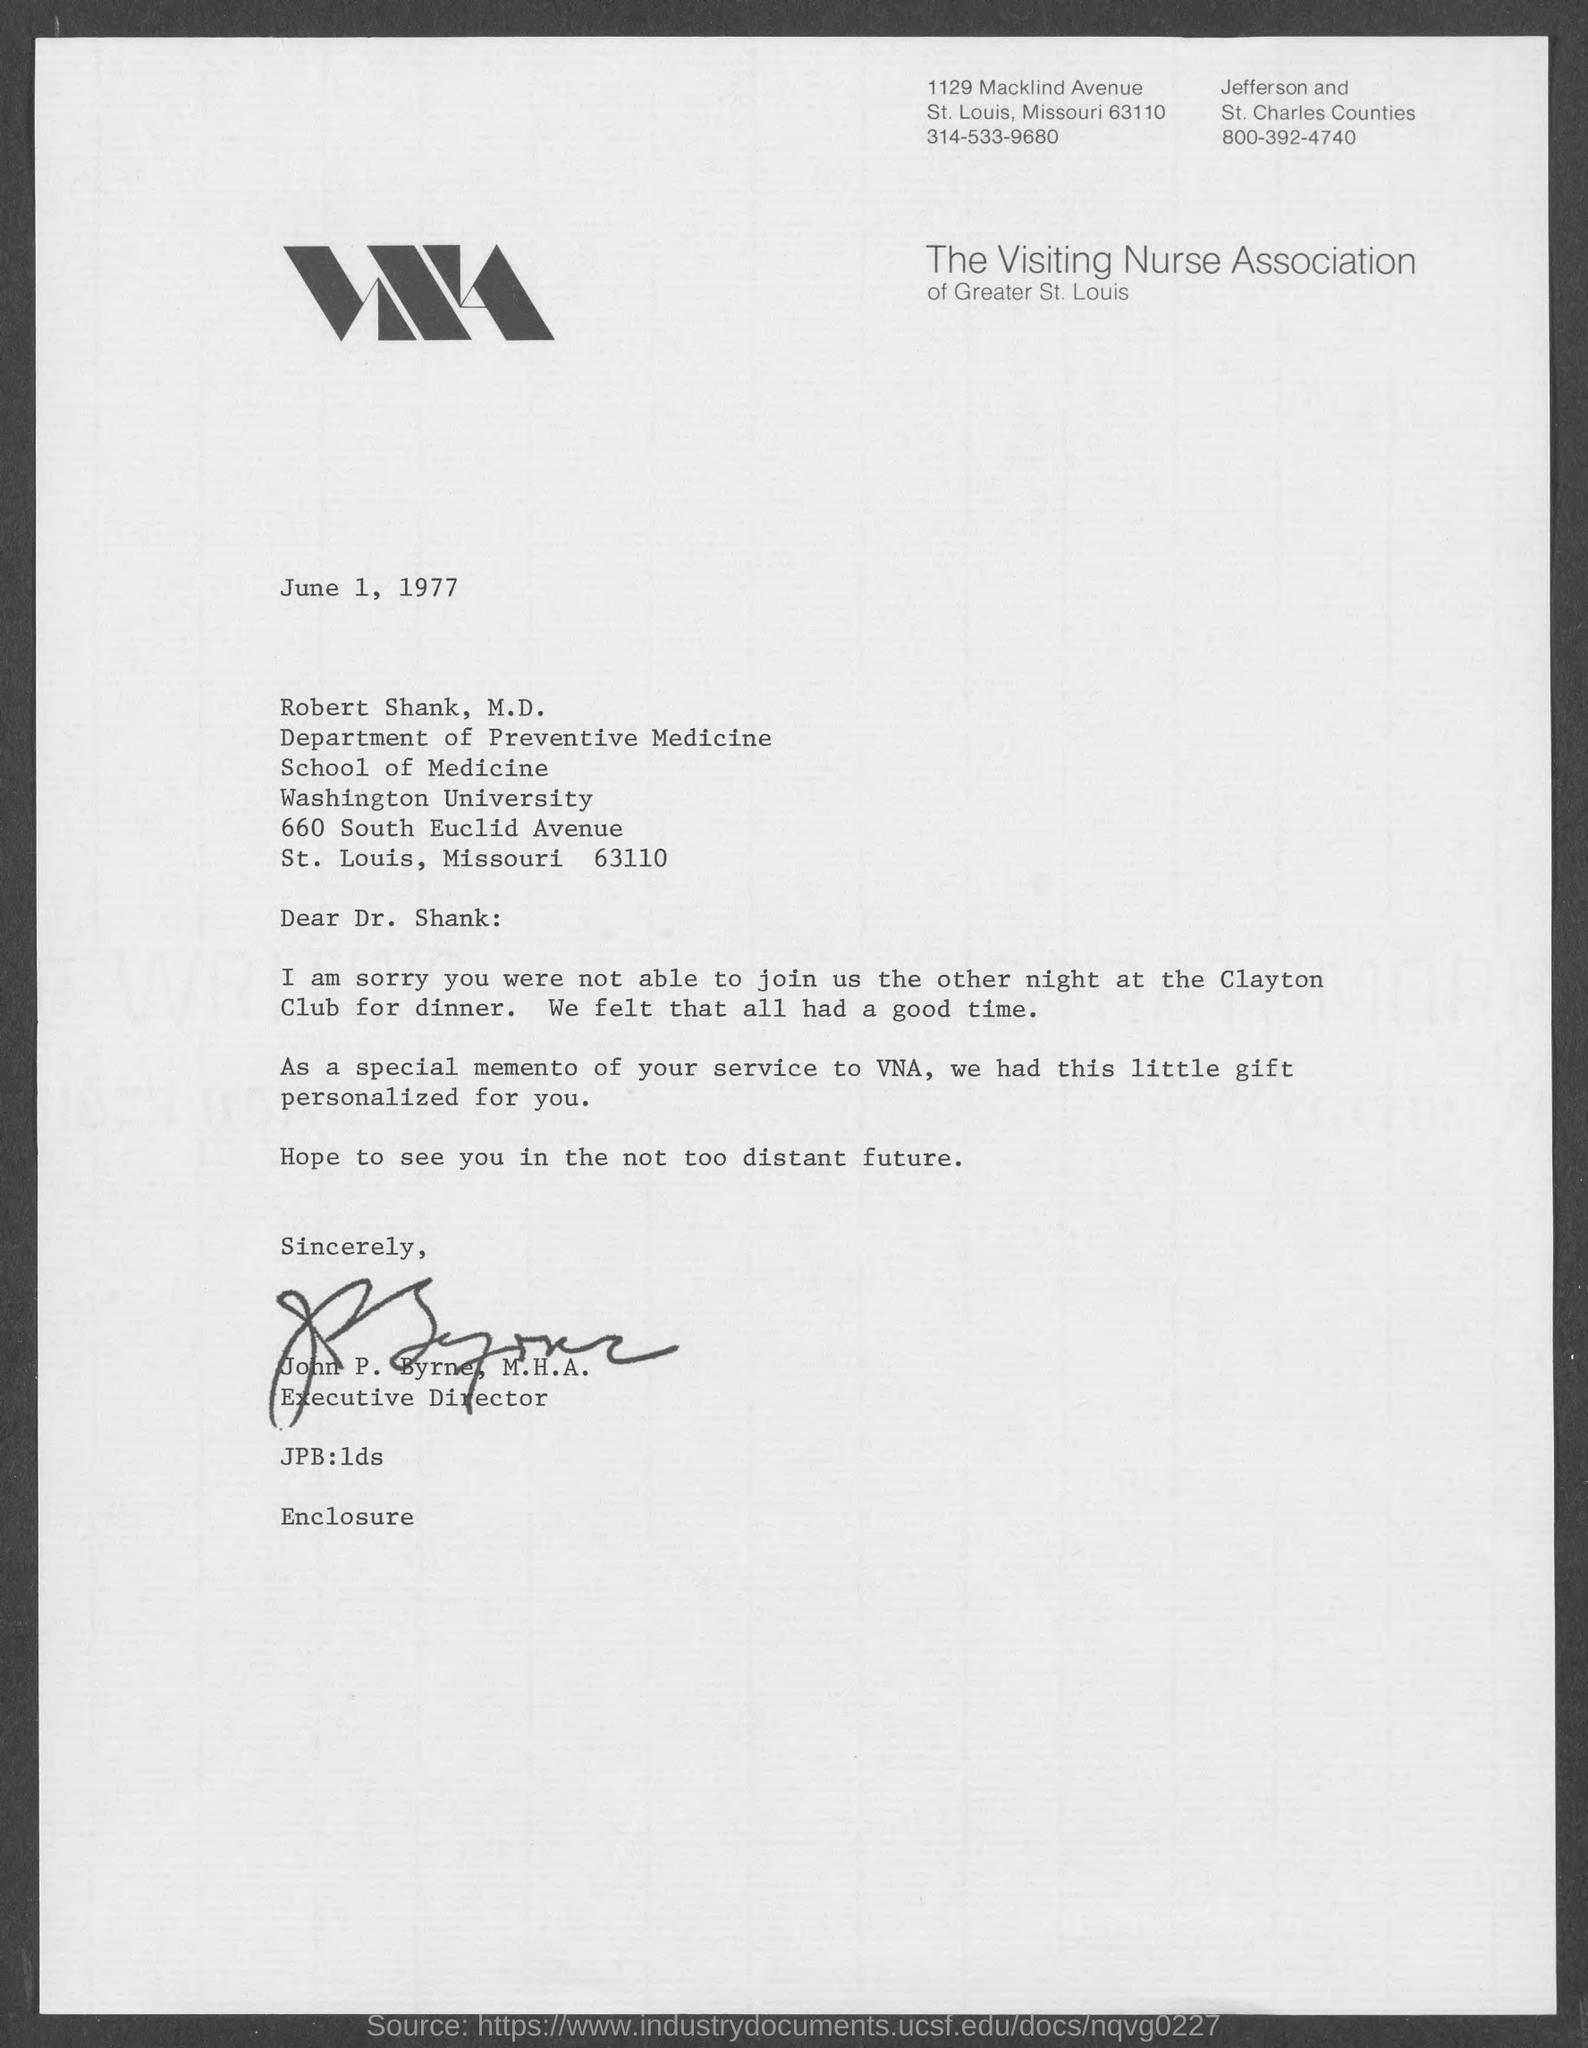List a handful of essential elements in this visual. The Visiting Nurse Association is mentioned in the letterhead of the document. The sender of this letter is John P. Byrne, who holds a Master's degree in Health Administration. John P. Byrne, who holds a Master's degree in Health Administration, is designated as the Executive Director. The date mentioned in this letter is June 1, 1977. 